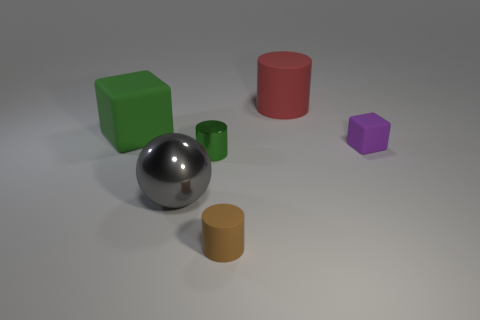How many objects are there, and can you distinguish their shapes? There are five objects in the image: a large green cube, a smaller yellow cylinder, a small purple pentagonal prism, a red cylinder, and a silver sphere. Their geometric shapes are easily distinguishable, each with a unique number of faces and silhouette. 